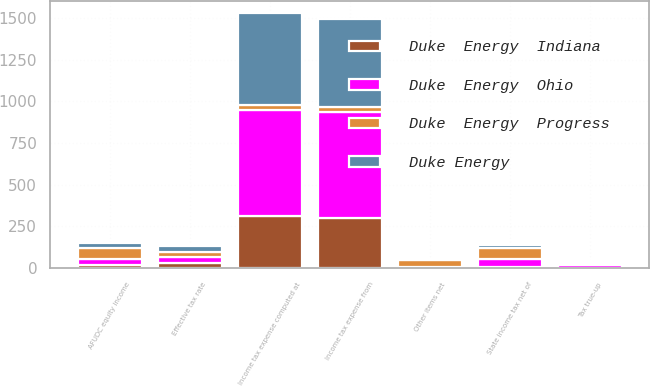Convert chart to OTSL. <chart><loc_0><loc_0><loc_500><loc_500><stacked_bar_chart><ecel><fcel>Income tax expense computed at<fcel>State income tax net of<fcel>AFUDC equity income<fcel>Tax true-up<fcel>Other items net<fcel>Income tax expense from<fcel>Effective tax rate<nl><fcel>Duke  Energy  Progress<fcel>33.55<fcel>64<fcel>70<fcel>14<fcel>39<fcel>33.55<fcel>31<nl><fcel>Duke  Energy  Ohio<fcel>630<fcel>46<fcel>36<fcel>14<fcel>5<fcel>634<fcel>35.2<nl><fcel>Duke Energy<fcel>548<fcel>20<fcel>26<fcel>11<fcel>4<fcel>527<fcel>33.7<nl><fcel>Duke  Energy  Indiana<fcel>315<fcel>10<fcel>17<fcel>3<fcel>4<fcel>301<fcel>33.4<nl></chart> 